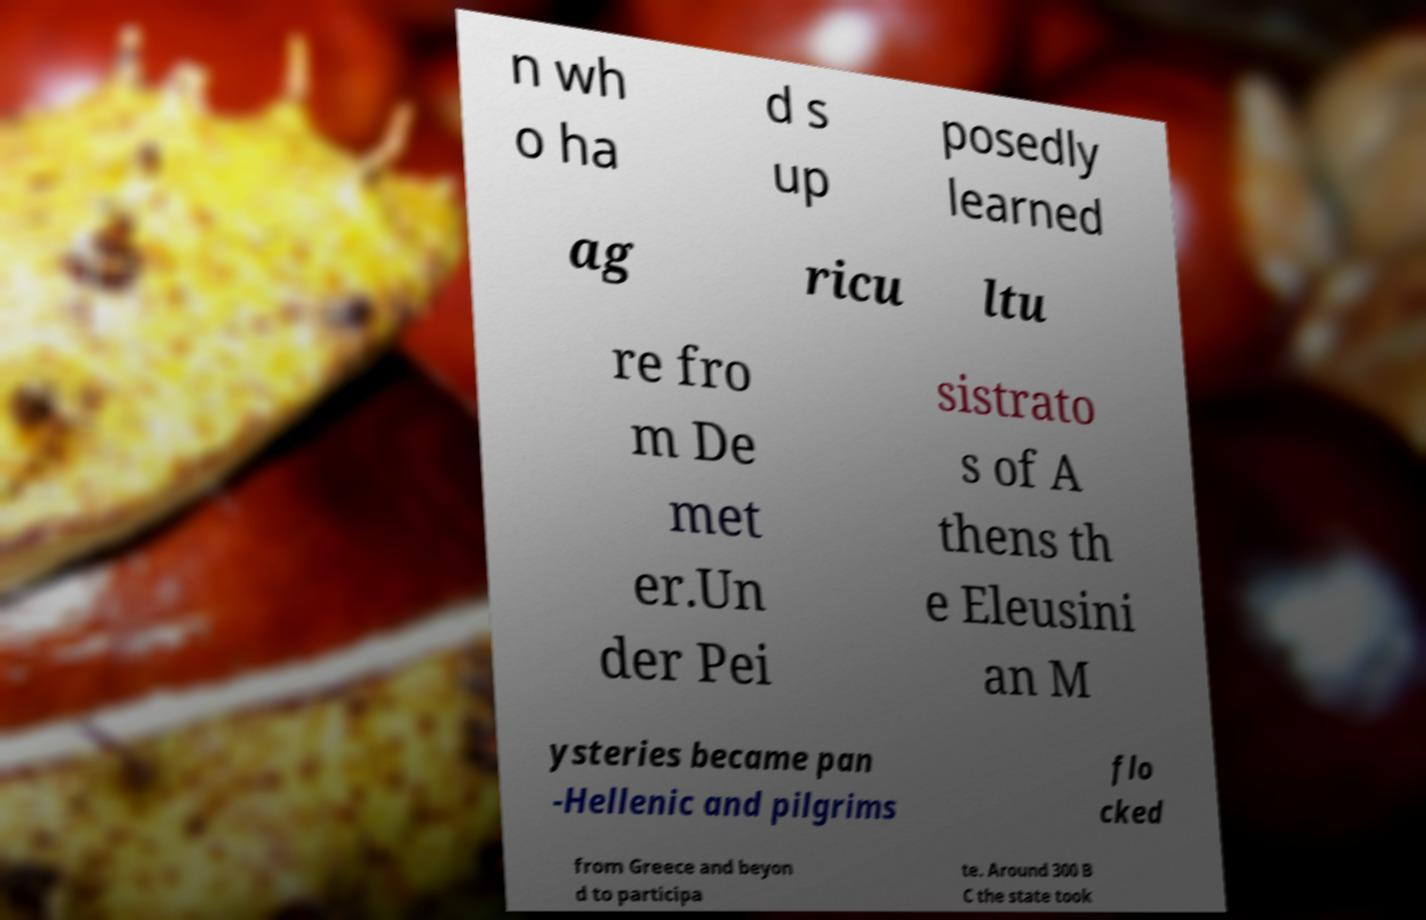I need the written content from this picture converted into text. Can you do that? n wh o ha d s up posedly learned ag ricu ltu re fro m De met er.Un der Pei sistrato s of A thens th e Eleusini an M ysteries became pan -Hellenic and pilgrims flo cked from Greece and beyon d to participa te. Around 300 B C the state took 